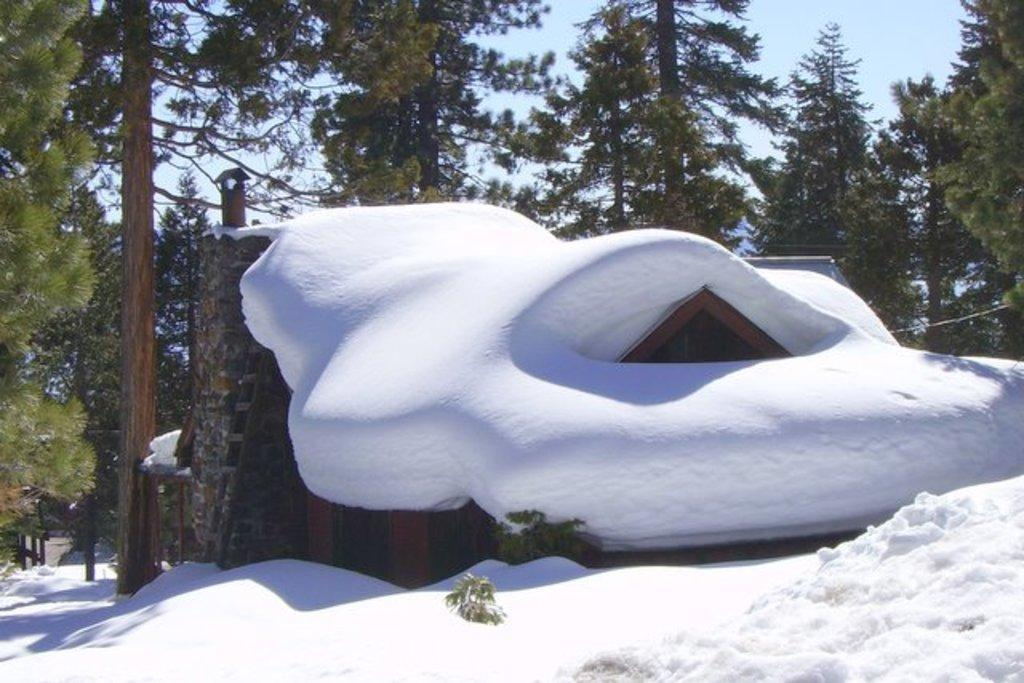What is the main subject of the image? The main subject of the image is a building. How is the building affected by the weather? The building is covered in snow. What can be seen in the background of the image? There are trees in the background of the image. What is visible above the building? The sky is visible above the building. What type of chain can be seen supporting the building in the image? There is no chain visible in the image, and the building is not being supported by any chains. 